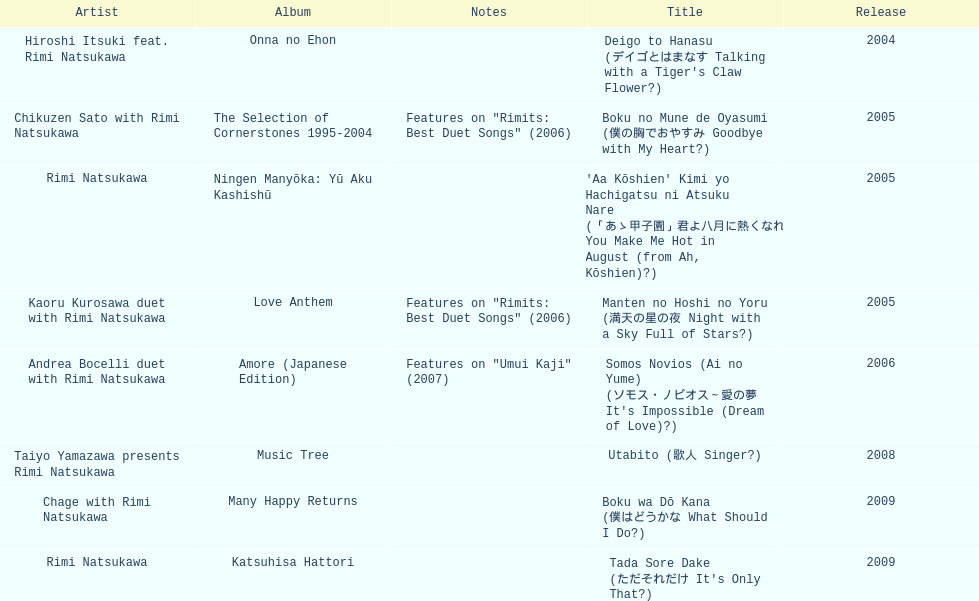How many other appearance did this artist make in 2005? 3. 